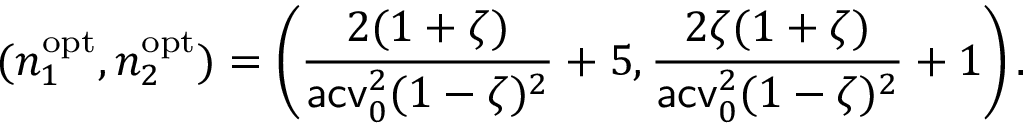<formula> <loc_0><loc_0><loc_500><loc_500>( n _ { 1 } ^ { o p t } , n _ { 2 } ^ { o p t } ) = \left ( \frac { 2 ( 1 + \zeta ) } { a c v _ { 0 } ^ { 2 } ( 1 - \zeta ) ^ { 2 } } + 5 , \frac { 2 \zeta ( 1 + \zeta ) } { a c v _ { 0 } ^ { 2 } ( 1 - \zeta ) ^ { 2 } } + 1 \right ) .</formula> 